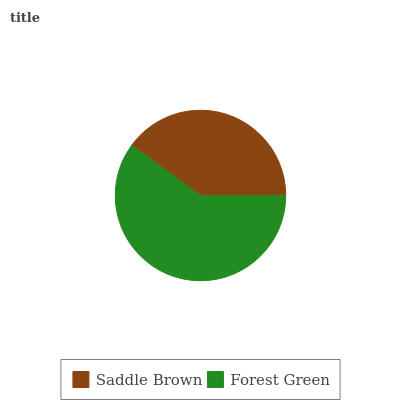Is Saddle Brown the minimum?
Answer yes or no. Yes. Is Forest Green the maximum?
Answer yes or no. Yes. Is Forest Green the minimum?
Answer yes or no. No. Is Forest Green greater than Saddle Brown?
Answer yes or no. Yes. Is Saddle Brown less than Forest Green?
Answer yes or no. Yes. Is Saddle Brown greater than Forest Green?
Answer yes or no. No. Is Forest Green less than Saddle Brown?
Answer yes or no. No. Is Forest Green the high median?
Answer yes or no. Yes. Is Saddle Brown the low median?
Answer yes or no. Yes. Is Saddle Brown the high median?
Answer yes or no. No. Is Forest Green the low median?
Answer yes or no. No. 